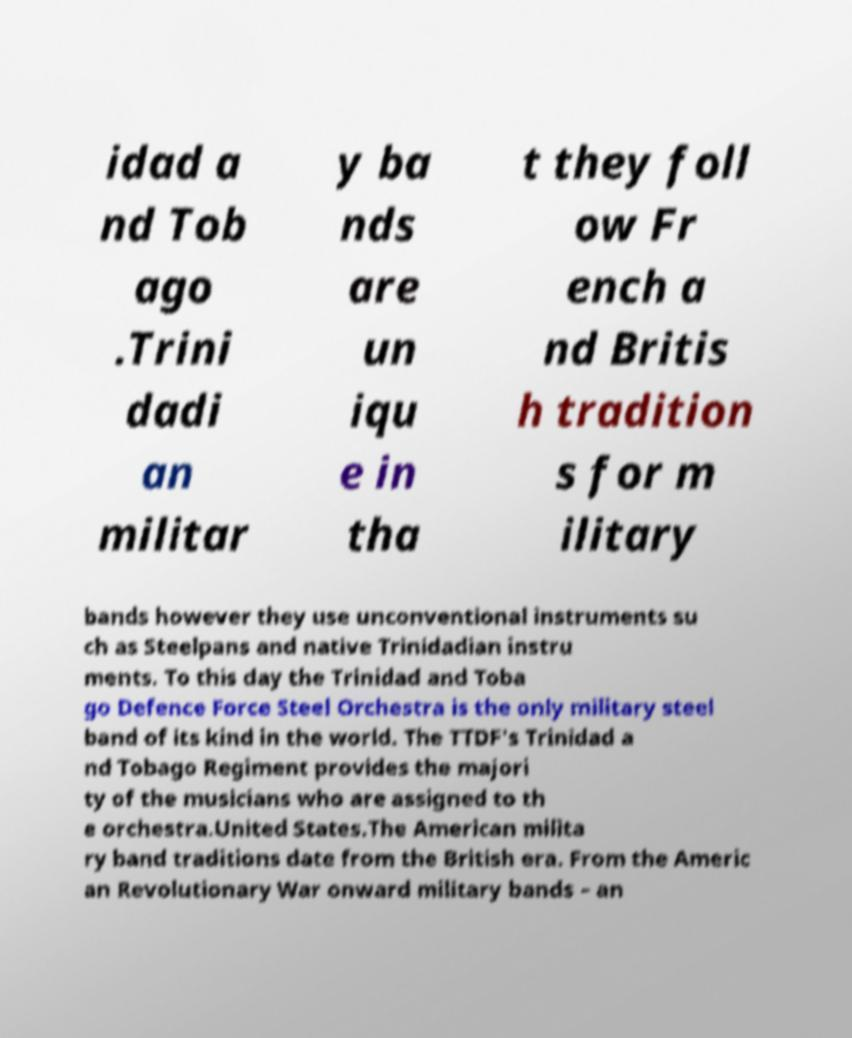For documentation purposes, I need the text within this image transcribed. Could you provide that? idad a nd Tob ago .Trini dadi an militar y ba nds are un iqu e in tha t they foll ow Fr ench a nd Britis h tradition s for m ilitary bands however they use unconventional instruments su ch as Steelpans and native Trinidadian instru ments. To this day the Trinidad and Toba go Defence Force Steel Orchestra is the only military steel band of its kind in the world. The TTDF's Trinidad a nd Tobago Regiment provides the majori ty of the musicians who are assigned to th e orchestra.United States.The American milita ry band traditions date from the British era. From the Americ an Revolutionary War onward military bands – an 